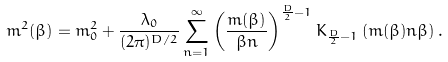<formula> <loc_0><loc_0><loc_500><loc_500>\ m ^ { 2 } ( \beta ) = m ^ { 2 } _ { 0 } + \frac { \lambda _ { 0 } } { ( 2 \pi ) ^ { D / 2 } } \sum ^ { \infty } _ { n = 1 } \left ( \frac { m ( \beta ) } { \beta n } \right ) ^ { \frac { D } { 2 } - 1 } K _ { \frac { D } { 2 } - 1 } \left ( m ( \beta ) n \beta \right ) .</formula> 